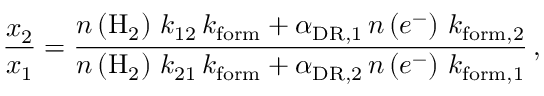Convert formula to latex. <formula><loc_0><loc_0><loc_500><loc_500>\frac { x _ { 2 } } { x _ { 1 } } = \frac { n \left ( H _ { 2 } \right ) \, k _ { 1 2 } \, k _ { f o r m } + \alpha _ { D R , 1 } \, n \left ( e ^ { - } \right ) \, k _ { f o r m , 2 } } { n \left ( H _ { 2 } \right ) \, k _ { 2 1 } \, k _ { f o r m } + \alpha _ { D R , 2 } \, n \left ( e ^ { - } \right ) \, k _ { f o r m , 1 } } \, ,</formula> 